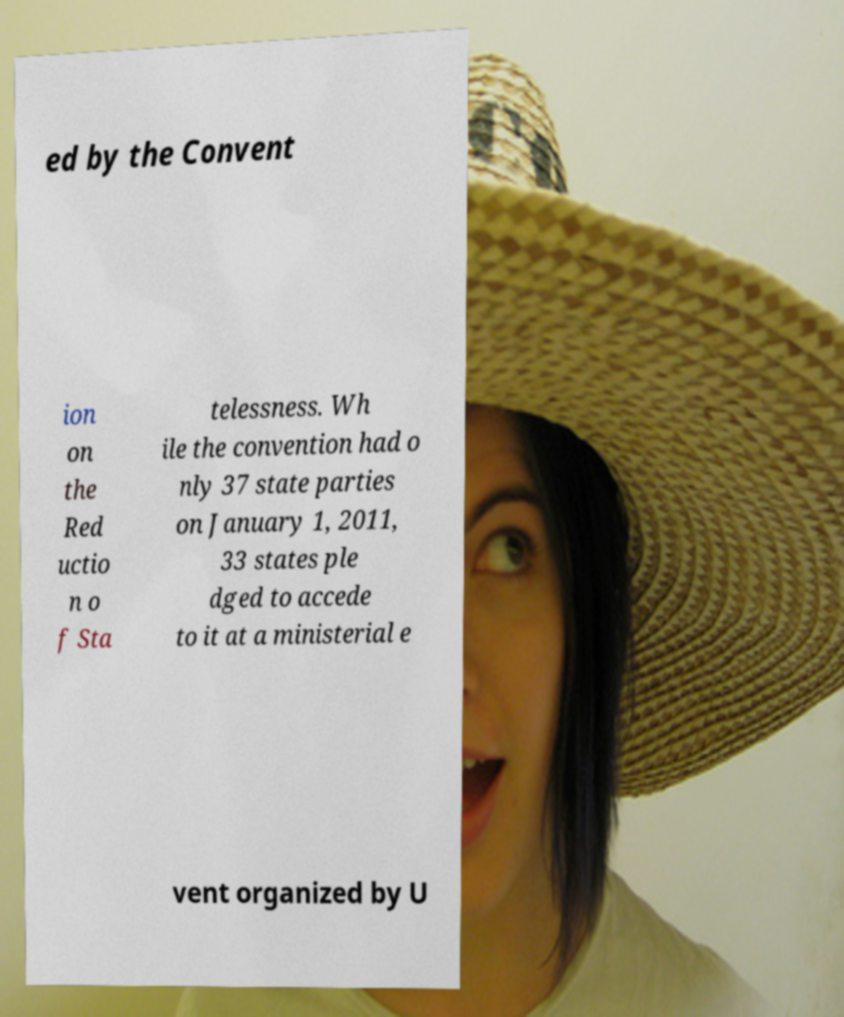Can you read and provide the text displayed in the image?This photo seems to have some interesting text. Can you extract and type it out for me? ed by the Convent ion on the Red uctio n o f Sta telessness. Wh ile the convention had o nly 37 state parties on January 1, 2011, 33 states ple dged to accede to it at a ministerial e vent organized by U 